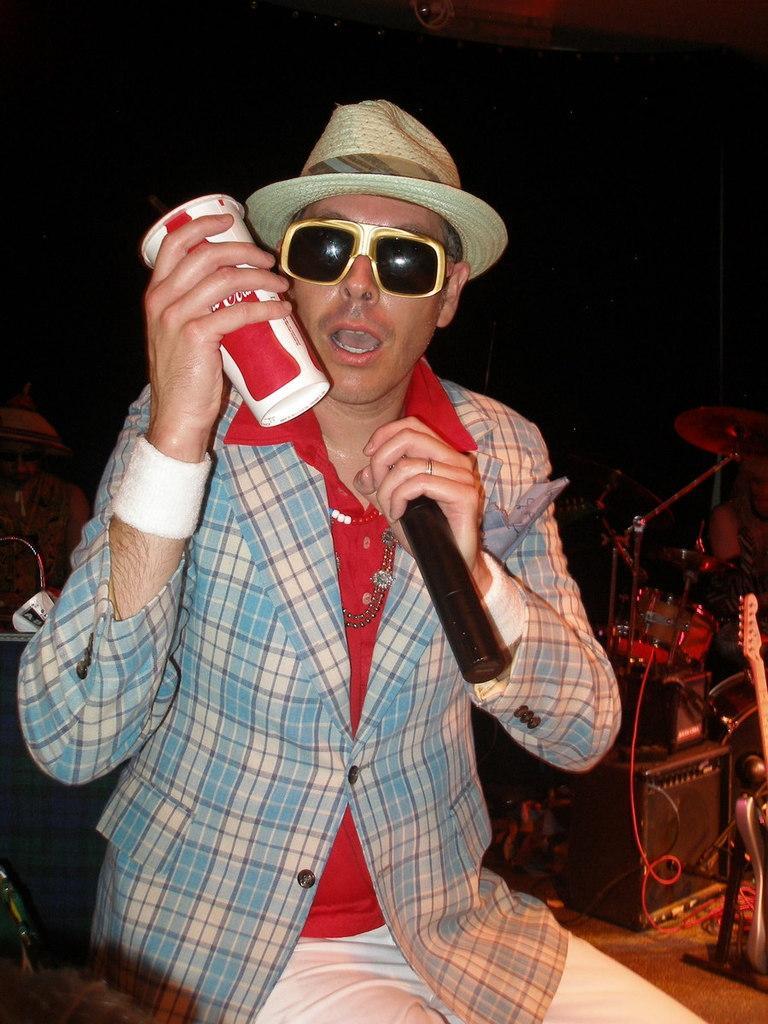Could you give a brief overview of what you see in this image? In this image I can see a person sitting and holding a cup and a microphone in his hands. I can see few musical instruments and the black colored background. 